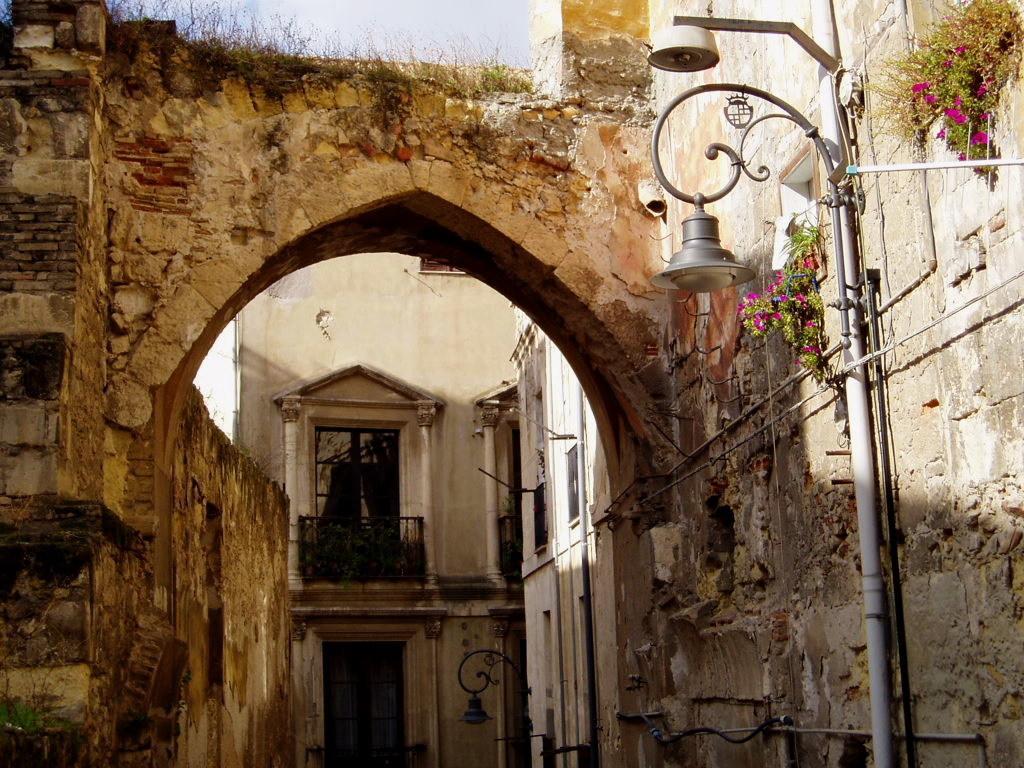In one or two sentences, can you explain what this image depicts? In this image we can see an arch, building, railings, plants, street poles, street lights and creeper plants. 